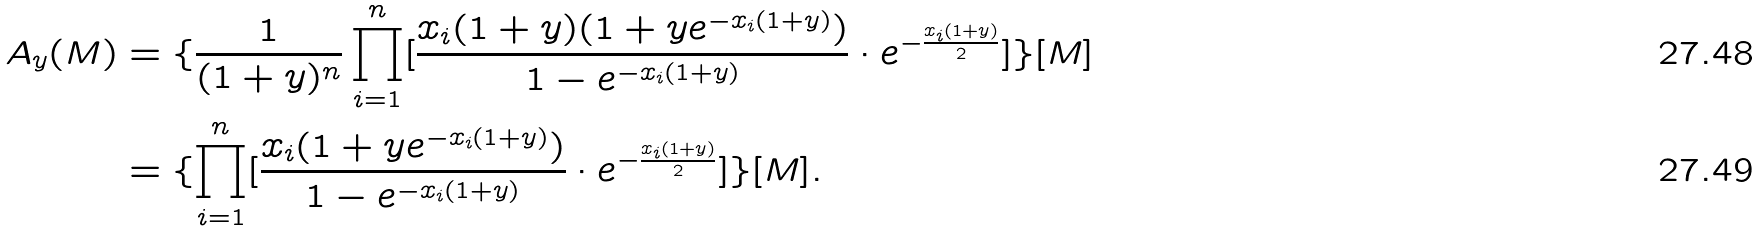<formula> <loc_0><loc_0><loc_500><loc_500>A _ { y } ( M ) & = \{ \frac { 1 } { ( 1 + y ) ^ { n } } \prod _ { i = 1 } ^ { n } [ \frac { x _ { i } ( 1 + y ) ( 1 + y e ^ { - x _ { i } ( 1 + y ) } ) } { 1 - e ^ { - x _ { i } ( 1 + y ) } } \cdot e ^ { - \frac { x _ { i } ( 1 + y ) } { 2 } } ] \} [ M ] \\ & = \{ \prod _ { i = 1 } ^ { n } [ \frac { x _ { i } ( 1 + y e ^ { - x _ { i } ( 1 + y ) } ) } { 1 - e ^ { - x _ { i } ( 1 + y ) } } \cdot e ^ { - \frac { x _ { i } ( 1 + y ) } { 2 } } ] \} [ M ] .</formula> 